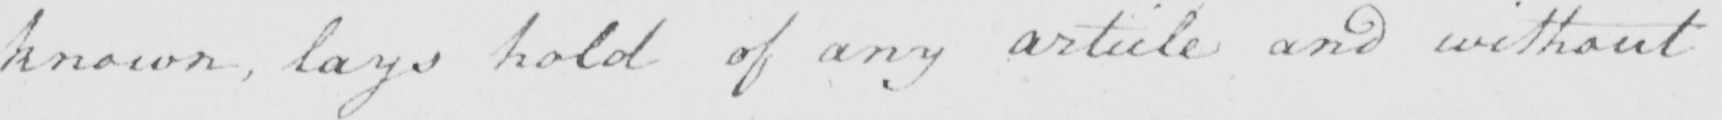Transcribe the text shown in this historical manuscript line. known , lays hold of any article and without 